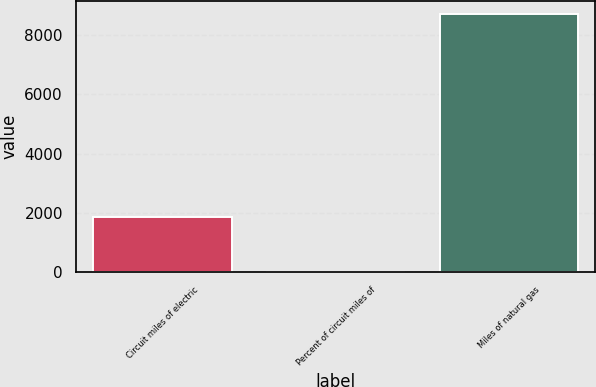<chart> <loc_0><loc_0><loc_500><loc_500><bar_chart><fcel>Circuit miles of electric<fcel>Percent of circuit miles of<fcel>Miles of natural gas<nl><fcel>1853<fcel>12<fcel>8722<nl></chart> 